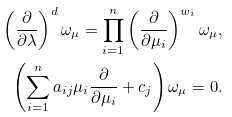<formula> <loc_0><loc_0><loc_500><loc_500>\left ( \frac { \partial } { \partial \lambda } \right ) ^ { d } \omega _ { \mu } = \prod _ { i = 1 } ^ { n } \left ( \frac { \partial } { \partial \mu _ { i } } \right ) ^ { w _ { i } } \omega _ { \mu } , \\ \left ( \sum _ { i = 1 } ^ { n } a _ { i j } \mu _ { i } \frac { \partial } { \partial \mu _ { i } } + c _ { j } \right ) \omega _ { \mu } = 0 .</formula> 